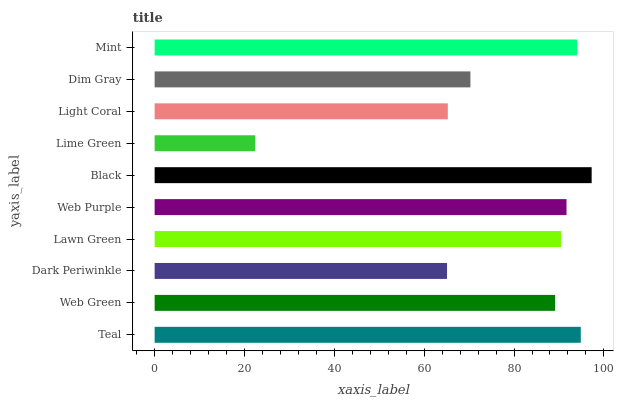Is Lime Green the minimum?
Answer yes or no. Yes. Is Black the maximum?
Answer yes or no. Yes. Is Web Green the minimum?
Answer yes or no. No. Is Web Green the maximum?
Answer yes or no. No. Is Teal greater than Web Green?
Answer yes or no. Yes. Is Web Green less than Teal?
Answer yes or no. Yes. Is Web Green greater than Teal?
Answer yes or no. No. Is Teal less than Web Green?
Answer yes or no. No. Is Lawn Green the high median?
Answer yes or no. Yes. Is Web Green the low median?
Answer yes or no. Yes. Is Lime Green the high median?
Answer yes or no. No. Is Mint the low median?
Answer yes or no. No. 